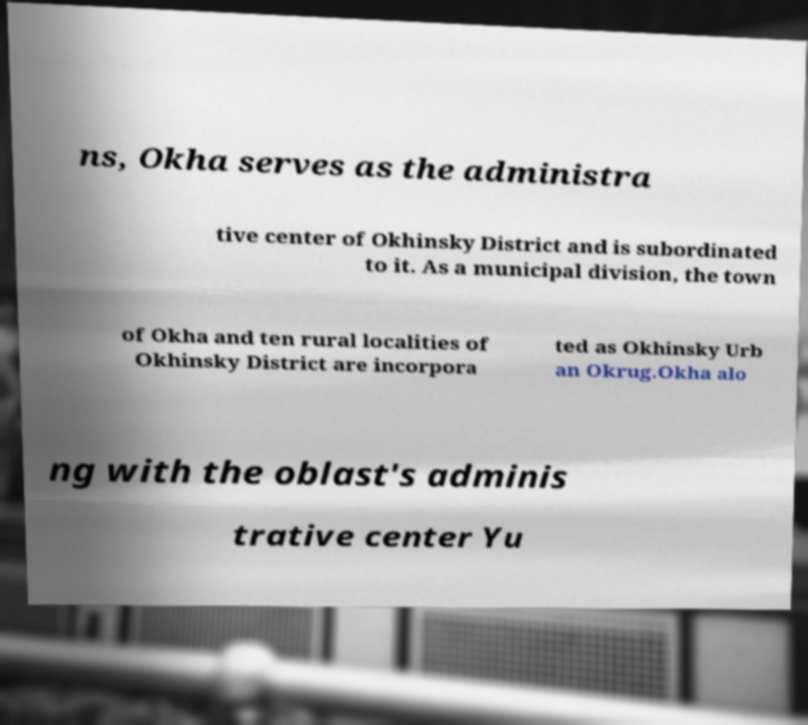Could you extract and type out the text from this image? ns, Okha serves as the administra tive center of Okhinsky District and is subordinated to it. As a municipal division, the town of Okha and ten rural localities of Okhinsky District are incorpora ted as Okhinsky Urb an Okrug.Okha alo ng with the oblast's adminis trative center Yu 